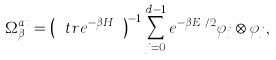Convert formula to latex. <formula><loc_0><loc_0><loc_500><loc_500>\Omega _ { \beta } ^ { a t } = \left ( \ t r e ^ { - \beta H _ { a t } } \right ) ^ { - 1 } \sum _ { j = 0 } ^ { d - 1 } e ^ { - \beta E _ { j } / 2 } \varphi _ { j } \otimes \varphi _ { j } ,</formula> 